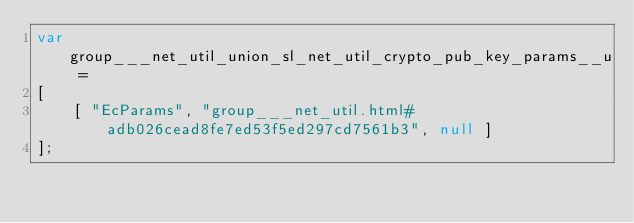<code> <loc_0><loc_0><loc_500><loc_500><_JavaScript_>var group___net_util_union_sl_net_util_crypto_pub_key_params__u =
[
    [ "EcParams", "group___net_util.html#adb026cead8fe7ed53f5ed297cd7561b3", null ]
];</code> 